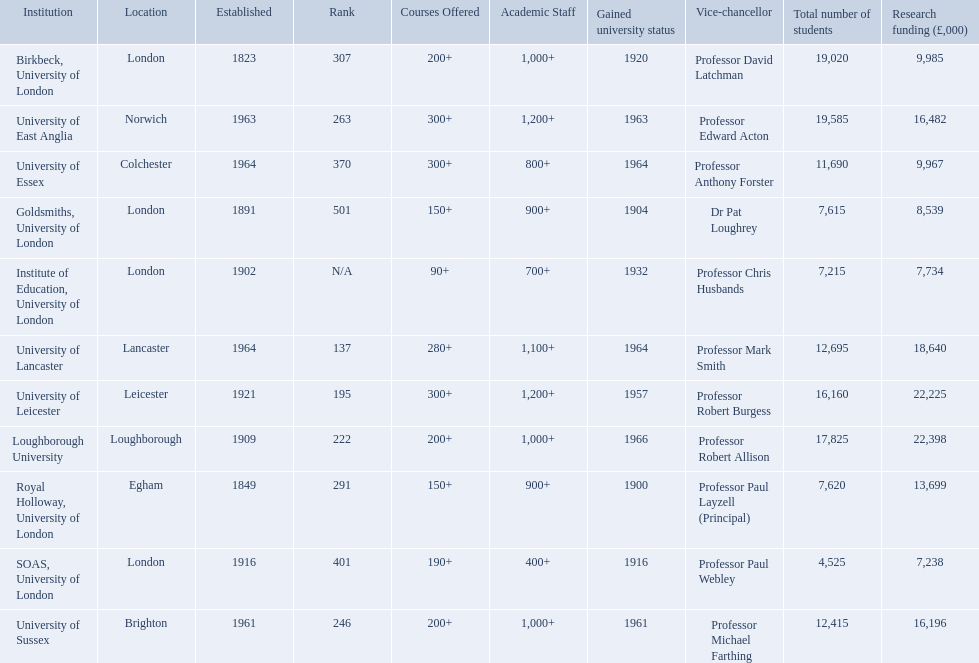What are the names of all the institutions? Birkbeck, University of London, University of East Anglia, University of Essex, Goldsmiths, University of London, Institute of Education, University of London, University of Lancaster, University of Leicester, Loughborough University, Royal Holloway, University of London, SOAS, University of London, University of Sussex. In what range of years were these institutions established? 1823, 1963, 1964, 1891, 1902, 1964, 1921, 1909, 1849, 1916, 1961. In what range of years did these institutions gain university status? 1920, 1963, 1964, 1904, 1932, 1964, 1957, 1966, 1900, 1916, 1961. What institution most recently gained university status? Loughborough University. 